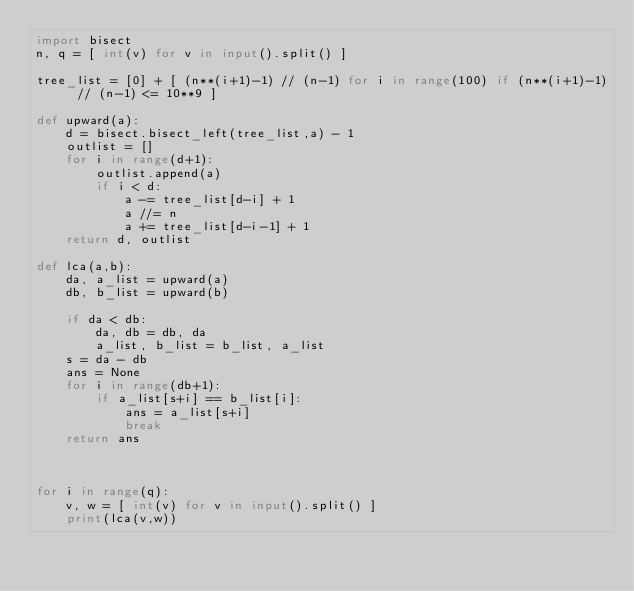<code> <loc_0><loc_0><loc_500><loc_500><_Python_>import bisect
n, q = [ int(v) for v in input().split() ]

tree_list = [0] + [ (n**(i+1)-1) // (n-1) for i in range(100) if (n**(i+1)-1) // (n-1) <= 10**9 ]

def upward(a):
    d = bisect.bisect_left(tree_list,a) - 1
    outlist = []
    for i in range(d+1):
        outlist.append(a)
        if i < d:
            a -= tree_list[d-i] + 1
            a //= n
            a += tree_list[d-i-1] + 1
    return d, outlist

def lca(a,b):
    da, a_list = upward(a)
    db, b_list = upward(b)

    if da < db:
        da, db = db, da
        a_list, b_list = b_list, a_list
    s = da - db
    ans = None
    for i in range(db+1):
        if a_list[s+i] == b_list[i]:
            ans = a_list[s+i]
            break
    return ans



for i in range(q):
    v, w = [ int(v) for v in input().split() ]
    print(lca(v,w))
</code> 